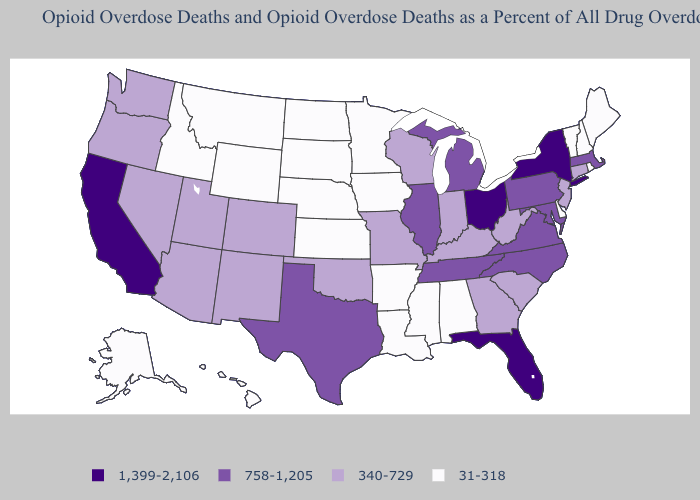What is the value of Washington?
Quick response, please. 340-729. Does Arkansas have the highest value in the USA?
Keep it brief. No. Name the states that have a value in the range 340-729?
Keep it brief. Arizona, Colorado, Connecticut, Georgia, Indiana, Kentucky, Missouri, Nevada, New Jersey, New Mexico, Oklahoma, Oregon, South Carolina, Utah, Washington, West Virginia, Wisconsin. Name the states that have a value in the range 758-1,205?
Be succinct. Illinois, Maryland, Massachusetts, Michigan, North Carolina, Pennsylvania, Tennessee, Texas, Virginia. What is the value of Utah?
Be succinct. 340-729. Which states have the lowest value in the USA?
Answer briefly. Alabama, Alaska, Arkansas, Delaware, Hawaii, Idaho, Iowa, Kansas, Louisiana, Maine, Minnesota, Mississippi, Montana, Nebraska, New Hampshire, North Dakota, Rhode Island, South Dakota, Vermont, Wyoming. Name the states that have a value in the range 1,399-2,106?
Keep it brief. California, Florida, New York, Ohio. What is the highest value in the South ?
Keep it brief. 1,399-2,106. Name the states that have a value in the range 340-729?
Short answer required. Arizona, Colorado, Connecticut, Georgia, Indiana, Kentucky, Missouri, Nevada, New Jersey, New Mexico, Oklahoma, Oregon, South Carolina, Utah, Washington, West Virginia, Wisconsin. What is the value of Washington?
Quick response, please. 340-729. What is the lowest value in states that border Iowa?
Concise answer only. 31-318. What is the value of Vermont?
Write a very short answer. 31-318. What is the highest value in the Northeast ?
Concise answer only. 1,399-2,106. What is the lowest value in states that border Delaware?
Answer briefly. 340-729. Which states have the lowest value in the USA?
Be succinct. Alabama, Alaska, Arkansas, Delaware, Hawaii, Idaho, Iowa, Kansas, Louisiana, Maine, Minnesota, Mississippi, Montana, Nebraska, New Hampshire, North Dakota, Rhode Island, South Dakota, Vermont, Wyoming. 